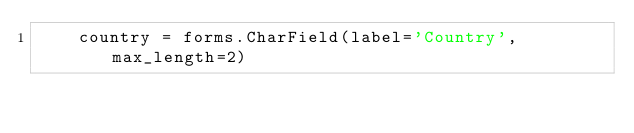Convert code to text. <code><loc_0><loc_0><loc_500><loc_500><_Python_>    country = forms.CharField(label='Country', max_length=2)
</code> 